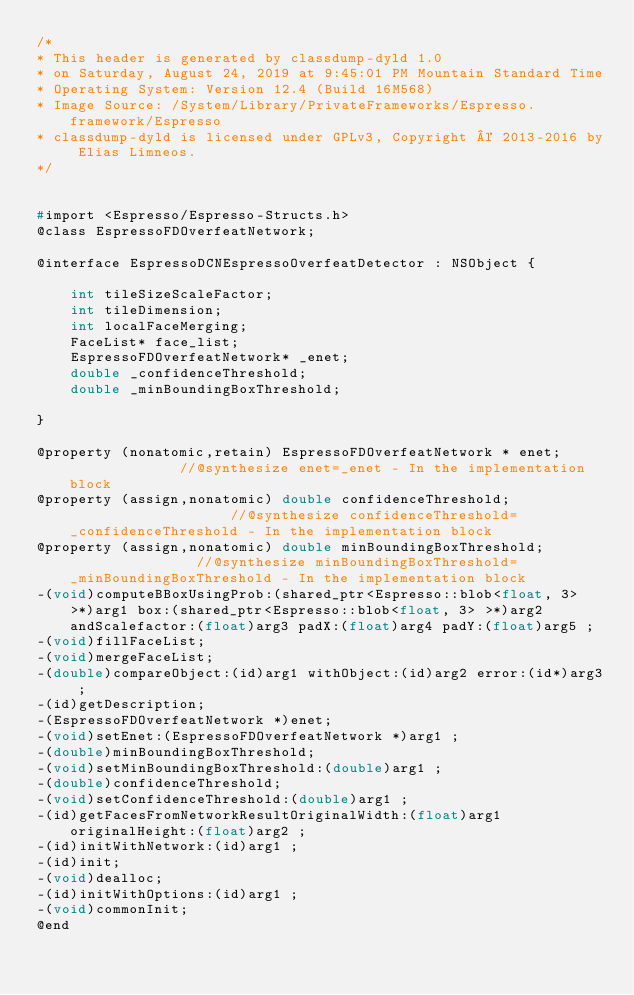<code> <loc_0><loc_0><loc_500><loc_500><_C_>/*
* This header is generated by classdump-dyld 1.0
* on Saturday, August 24, 2019 at 9:45:01 PM Mountain Standard Time
* Operating System: Version 12.4 (Build 16M568)
* Image Source: /System/Library/PrivateFrameworks/Espresso.framework/Espresso
* classdump-dyld is licensed under GPLv3, Copyright © 2013-2016 by Elias Limneos.
*/


#import <Espresso/Espresso-Structs.h>
@class EspressoFDOverfeatNetwork;

@interface EspressoDCNEspressoOverfeatDetector : NSObject {

	int tileSizeScaleFactor;
	int tileDimension;
	int localFaceMerging;
	FaceList* face_list;
	EspressoFDOverfeatNetwork* _enet;
	double _confidenceThreshold;
	double _minBoundingBoxThreshold;

}

@property (nonatomic,retain) EspressoFDOverfeatNetwork * enet;              //@synthesize enet=_enet - In the implementation block
@property (assign,nonatomic) double confidenceThreshold;                    //@synthesize confidenceThreshold=_confidenceThreshold - In the implementation block
@property (assign,nonatomic) double minBoundingBoxThreshold;                //@synthesize minBoundingBoxThreshold=_minBoundingBoxThreshold - In the implementation block
-(void)computeBBoxUsingProb:(shared_ptr<Espresso::blob<float, 3> >*)arg1 box:(shared_ptr<Espresso::blob<float, 3> >*)arg2 andScalefactor:(float)arg3 padX:(float)arg4 padY:(float)arg5 ;
-(void)fillFaceList;
-(void)mergeFaceList;
-(double)compareObject:(id)arg1 withObject:(id)arg2 error:(id*)arg3 ;
-(id)getDescription;
-(EspressoFDOverfeatNetwork *)enet;
-(void)setEnet:(EspressoFDOverfeatNetwork *)arg1 ;
-(double)minBoundingBoxThreshold;
-(void)setMinBoundingBoxThreshold:(double)arg1 ;
-(double)confidenceThreshold;
-(void)setConfidenceThreshold:(double)arg1 ;
-(id)getFacesFromNetworkResultOriginalWidth:(float)arg1 originalHeight:(float)arg2 ;
-(id)initWithNetwork:(id)arg1 ;
-(id)init;
-(void)dealloc;
-(id)initWithOptions:(id)arg1 ;
-(void)commonInit;
@end

</code> 